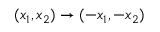<formula> <loc_0><loc_0><loc_500><loc_500>( x _ { 1 } , x _ { 2 } ) \to ( - x _ { 1 } , - x _ { 2 } )</formula> 